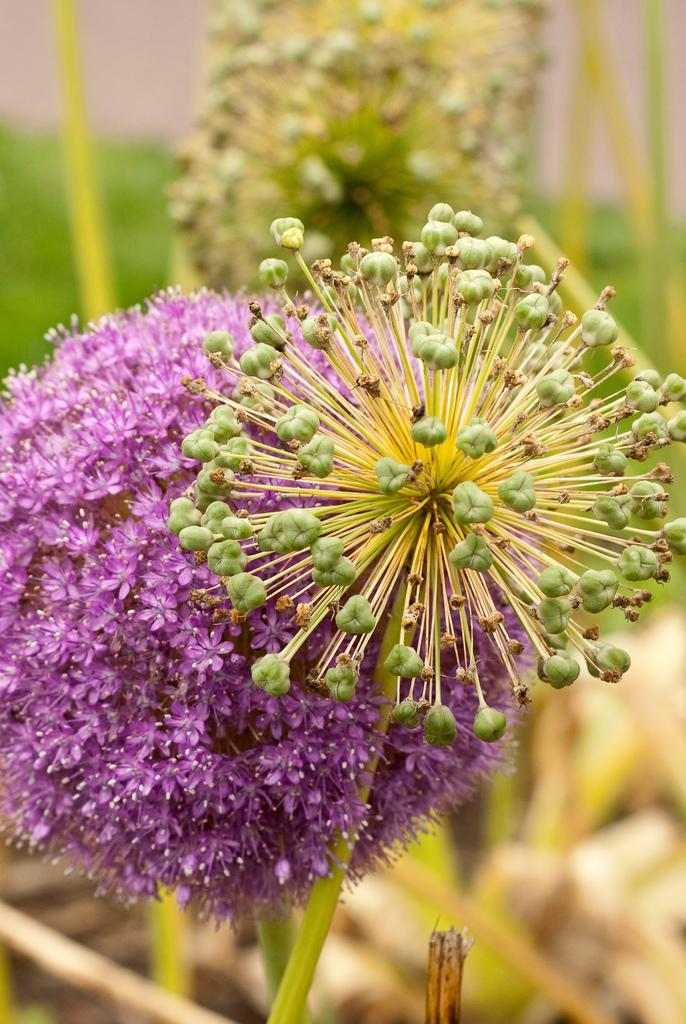What type of plants are in the image? There are flowers in the image. What part of the flowers is visible in the image? The flowers have stems in the image. How would you describe the background of the image? The background of the image is blurred. What type of suggestion can be seen in the image? There is no suggestion present in the image; it features flowers with stems and a blurred background. How many circles are visible in the image? There are no circles present in the image. 